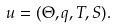Convert formula to latex. <formula><loc_0><loc_0><loc_500><loc_500>u = ( \Theta , q , T , S ) .</formula> 